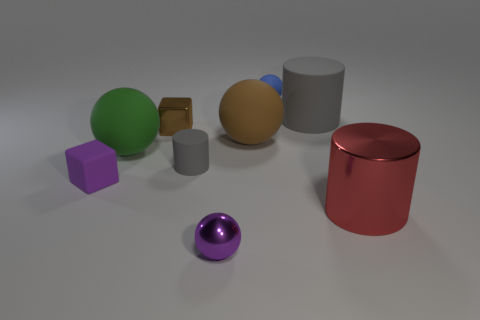What is the material of the ball left of the tiny gray cylinder?
Provide a short and direct response. Rubber. Is there anything else that is the same material as the tiny purple cube?
Keep it short and to the point. Yes. Is the number of matte cubes behind the brown matte ball greater than the number of green matte balls?
Keep it short and to the point. No. Are there any gray cylinders that are in front of the gray cylinder behind the tiny metal thing left of the purple shiny ball?
Keep it short and to the point. Yes. Are there any big green rubber objects behind the green sphere?
Provide a succinct answer. No. What number of rubber things have the same color as the tiny shiny cube?
Make the answer very short. 1. There is a brown sphere that is the same material as the tiny purple cube; what is its size?
Your response must be concise. Large. What is the size of the gray matte object that is on the right side of the sphere in front of the small purple thing behind the large metallic cylinder?
Your answer should be very brief. Large. There is a gray rubber thing in front of the tiny brown block; what is its size?
Provide a short and direct response. Small. What number of brown things are metal balls or metallic things?
Give a very brief answer. 1. 